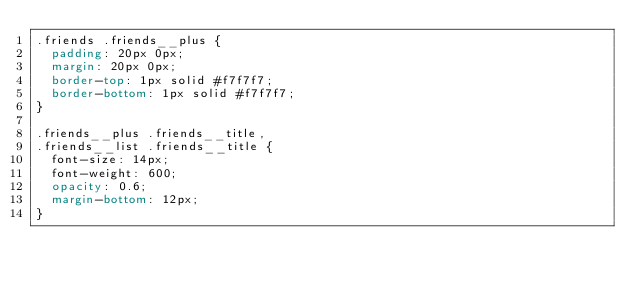<code> <loc_0><loc_0><loc_500><loc_500><_CSS_>.friends .friends__plus {
  padding: 20px 0px;
  margin: 20px 0px;
  border-top: 1px solid #f7f7f7;
  border-bottom: 1px solid #f7f7f7;
}

.friends__plus .friends__title,
.friends__list .friends__title {
  font-size: 14px;
  font-weight: 600;
  opacity: 0.6;
  margin-bottom: 12px;
}
</code> 